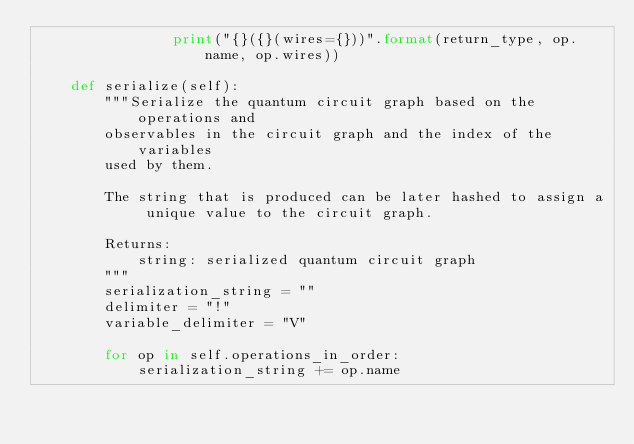Convert code to text. <code><loc_0><loc_0><loc_500><loc_500><_Python_>                print("{}({}(wires={}))".format(return_type, op.name, op.wires))

    def serialize(self):
        """Serialize the quantum circuit graph based on the operations and
        observables in the circuit graph and the index of the variables
        used by them.

        The string that is produced can be later hashed to assign a unique value to the circuit graph.

        Returns:
            string: serialized quantum circuit graph
        """
        serialization_string = ""
        delimiter = "!"
        variable_delimiter = "V"

        for op in self.operations_in_order:
            serialization_string += op.name
</code> 